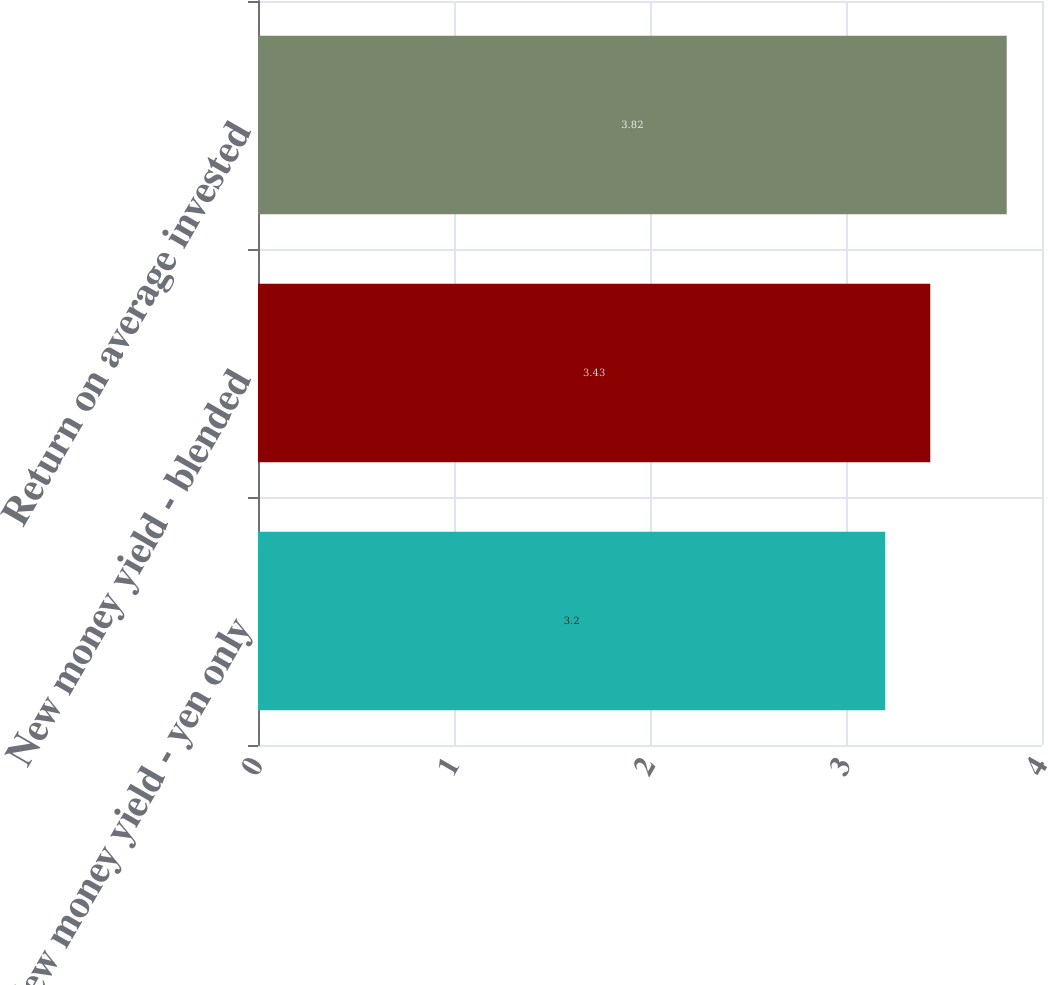<chart> <loc_0><loc_0><loc_500><loc_500><bar_chart><fcel>New money yield - yen only<fcel>New money yield - blended<fcel>Return on average invested<nl><fcel>3.2<fcel>3.43<fcel>3.82<nl></chart> 